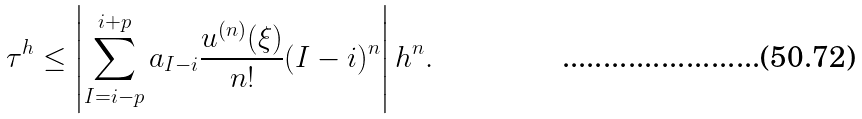Convert formula to latex. <formula><loc_0><loc_0><loc_500><loc_500>\tau ^ { h } \leq \left | \sum ^ { i + p } _ { I = i - p } a _ { I - i } \frac { u ^ { ( n ) } ( \xi ) } { n ! } ( I - i ) ^ { n } \right | h ^ { n } .</formula> 